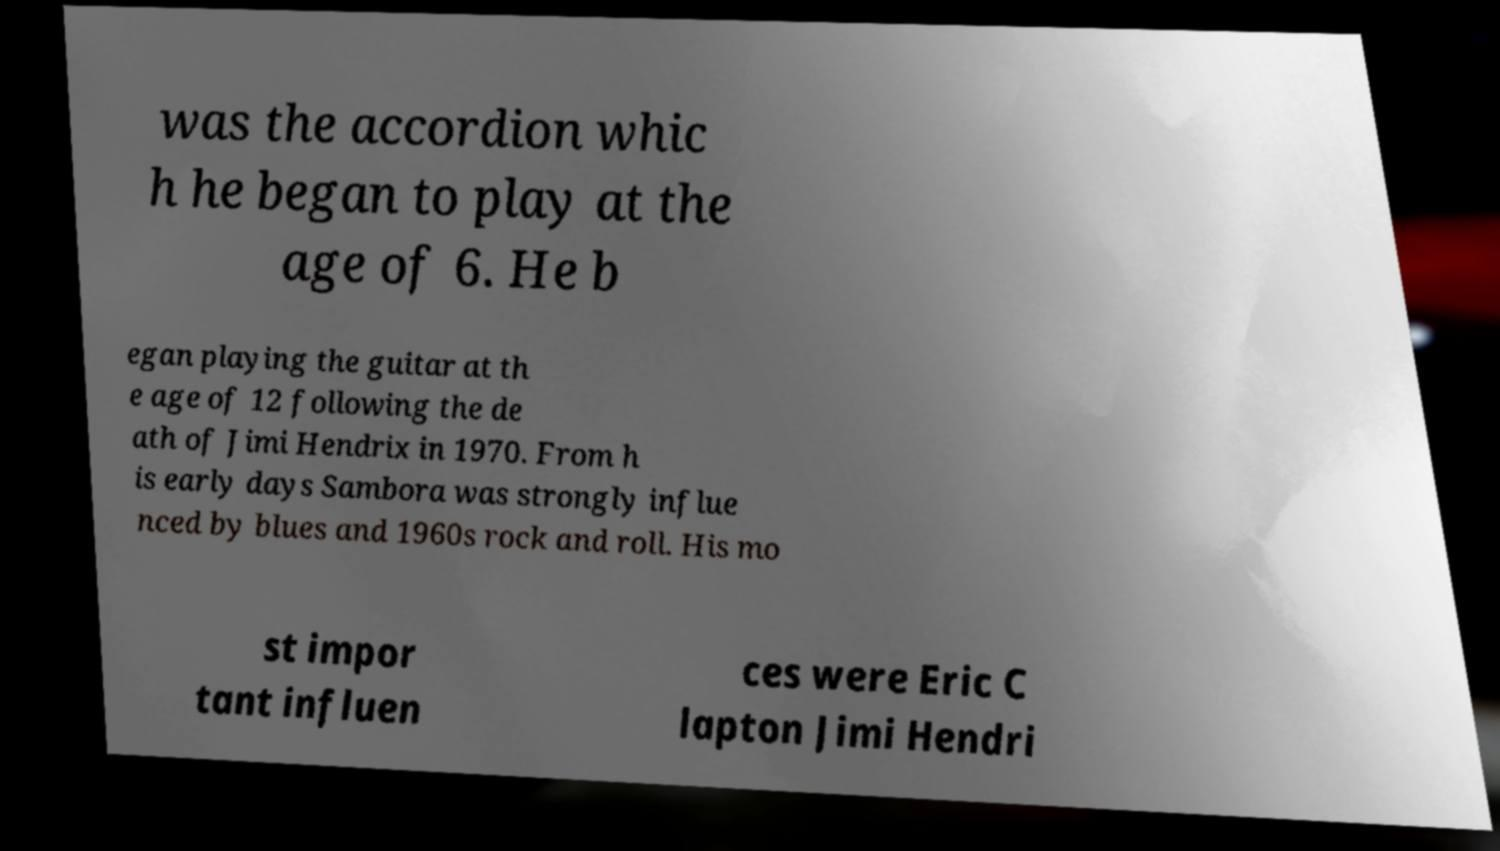Please read and relay the text visible in this image. What does it say? was the accordion whic h he began to play at the age of 6. He b egan playing the guitar at th e age of 12 following the de ath of Jimi Hendrix in 1970. From h is early days Sambora was strongly influe nced by blues and 1960s rock and roll. His mo st impor tant influen ces were Eric C lapton Jimi Hendri 